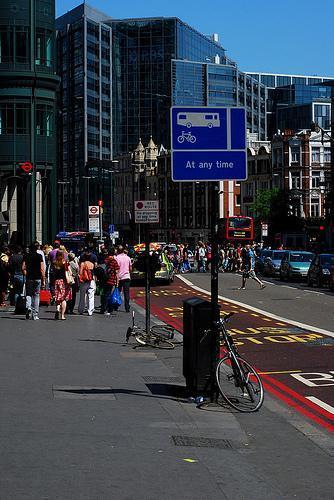How many bikes have fallen down?
Give a very brief answer. 1. 